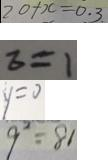Convert formula to latex. <formula><loc_0><loc_0><loc_500><loc_500>2 0 + x = 0 . 3 . 
 z = 1 
 y = 0 
 9 ^ { 2 } = 8 1</formula> 